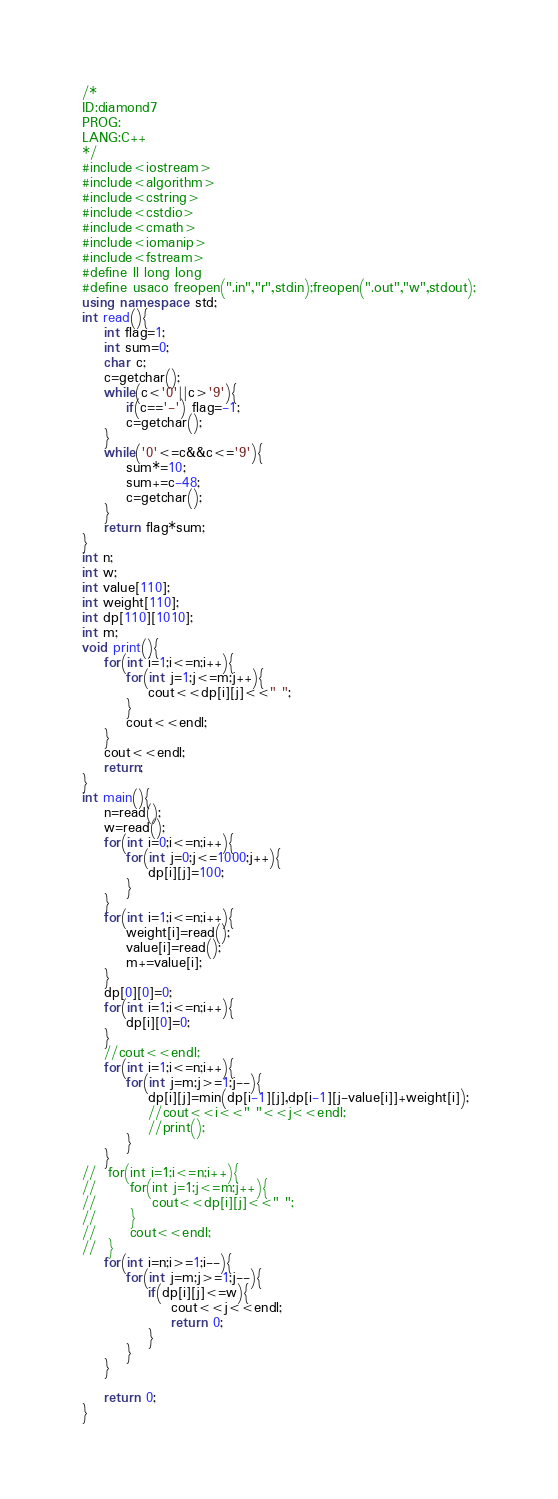Convert code to text. <code><loc_0><loc_0><loc_500><loc_500><_C++_>/*
ID:diamond7
PROG:
LANG:C++
*/
#include<iostream>
#include<algorithm>
#include<cstring>
#include<cstdio>
#include<cmath>
#include<iomanip>
#include<fstream>
#define ll long long
#define usaco freopen(".in","r",stdin);freopen(".out","w",stdout);
using namespace std;
int read(){
	int flag=1;
	int sum=0;
	char c;
	c=getchar();
	while(c<'0'||c>'9'){
		if(c=='-') flag=-1;
		c=getchar();
	}
	while('0'<=c&&c<='9'){
		sum*=10;
		sum+=c-48;
		c=getchar();
	}
	return flag*sum;
}
int n;
int w;
int value[110];
int weight[110];
int dp[110][1010];
int m;
void print(){
	for(int i=1;i<=n;i++){
		for(int j=1;j<=m;j++){
			cout<<dp[i][j]<<" ";
		}
		cout<<endl;
	}
	cout<<endl;
	return;
}
int main(){
	n=read();
	w=read();
	for(int i=0;i<=n;i++){
		for(int j=0;j<=1000;j++){
			dp[i][j]=100;
		}
	}
	for(int i=1;i<=n;i++){
		weight[i]=read();
		value[i]=read();
		m+=value[i];
	}
	dp[0][0]=0;
	for(int i=1;i<=n;i++){
		dp[i][0]=0;
	}
	//cout<<endl;
	for(int i=1;i<=n;i++){
		for(int j=m;j>=1;j--){
			dp[i][j]=min(dp[i-1][j],dp[i-1][j-value[i]]+weight[i]);
			//cout<<i<<" "<<j<<endl;
			//print();
		}
	}
//	for(int i=1;i<=n;i++){
//		for(int j=1;j<=m;j++){
//			cout<<dp[i][j]<<" ";
//		}
//		cout<<endl;
//	}
	for(int i=n;i>=1;i--){
		for(int j=m;j>=1;j--){
			if(dp[i][j]<=w){
				cout<<j<<endl;
				return 0;
			}
		}
	}
	
	return 0;
}


</code> 